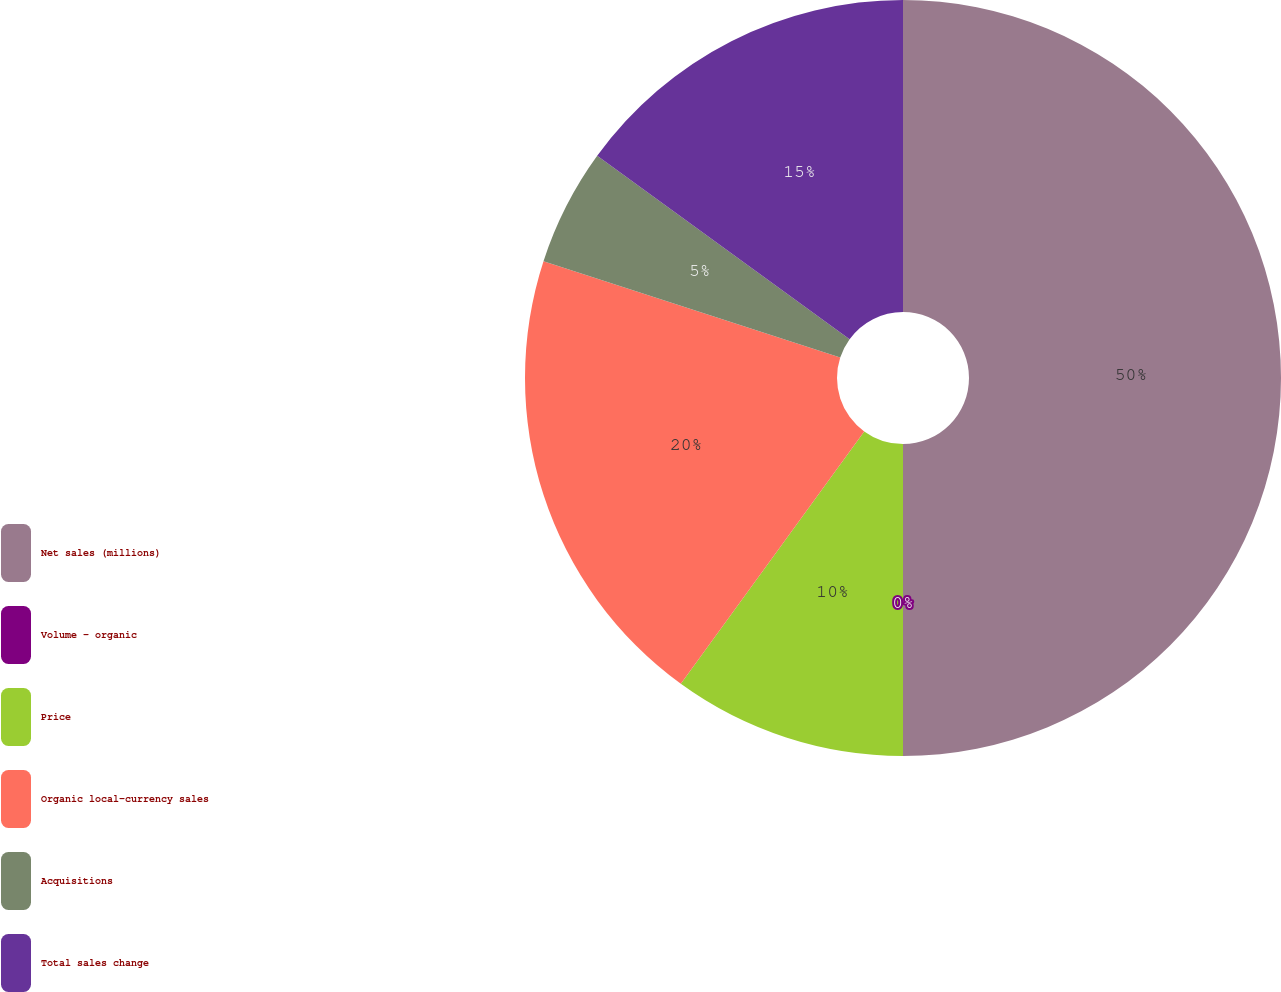Convert chart to OTSL. <chart><loc_0><loc_0><loc_500><loc_500><pie_chart><fcel>Net sales (millions)<fcel>Volume - organic<fcel>Price<fcel>Organic local-currency sales<fcel>Acquisitions<fcel>Total sales change<nl><fcel>50.0%<fcel>0.0%<fcel>10.0%<fcel>20.0%<fcel>5.0%<fcel>15.0%<nl></chart> 